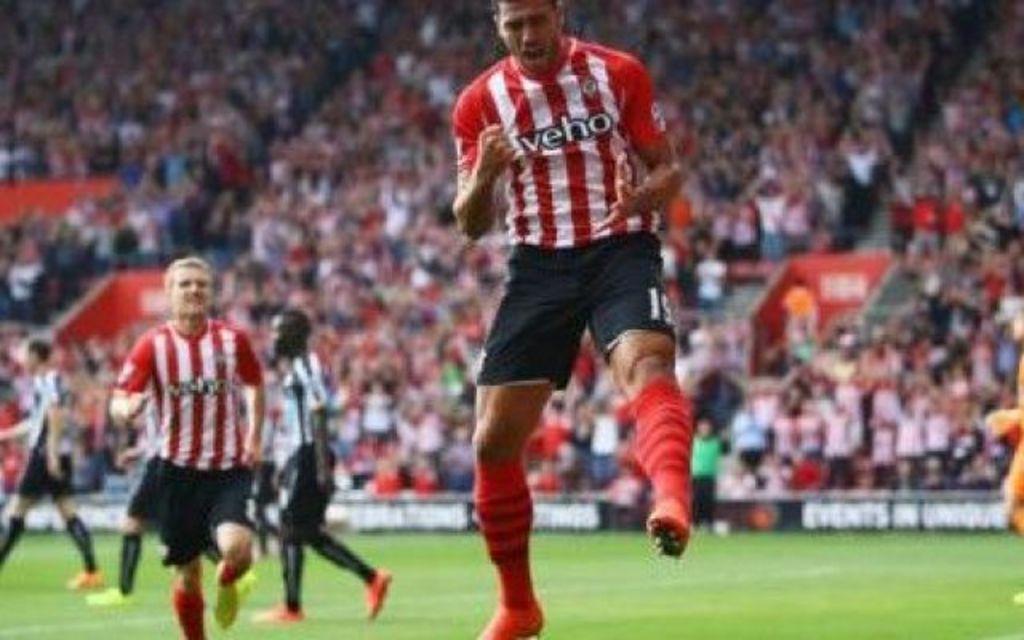How would you summarize this image in a sentence or two? In this image, we can see people on the ground and in the background, there is a crowd and we can see some boards. 